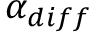Convert formula to latex. <formula><loc_0><loc_0><loc_500><loc_500>\alpha _ { d i f f }</formula> 